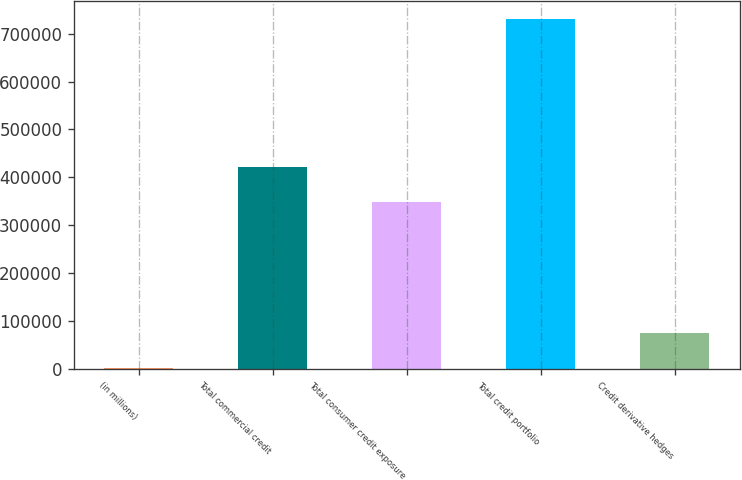Convert chart to OTSL. <chart><loc_0><loc_0><loc_500><loc_500><bar_chart><fcel>(in millions)<fcel>Total commercial credit<fcel>Total consumer credit exposure<fcel>Total credit portfolio<fcel>Credit derivative hedges<nl><fcel>2003<fcel>421091<fcel>348200<fcel>730914<fcel>74894.1<nl></chart> 